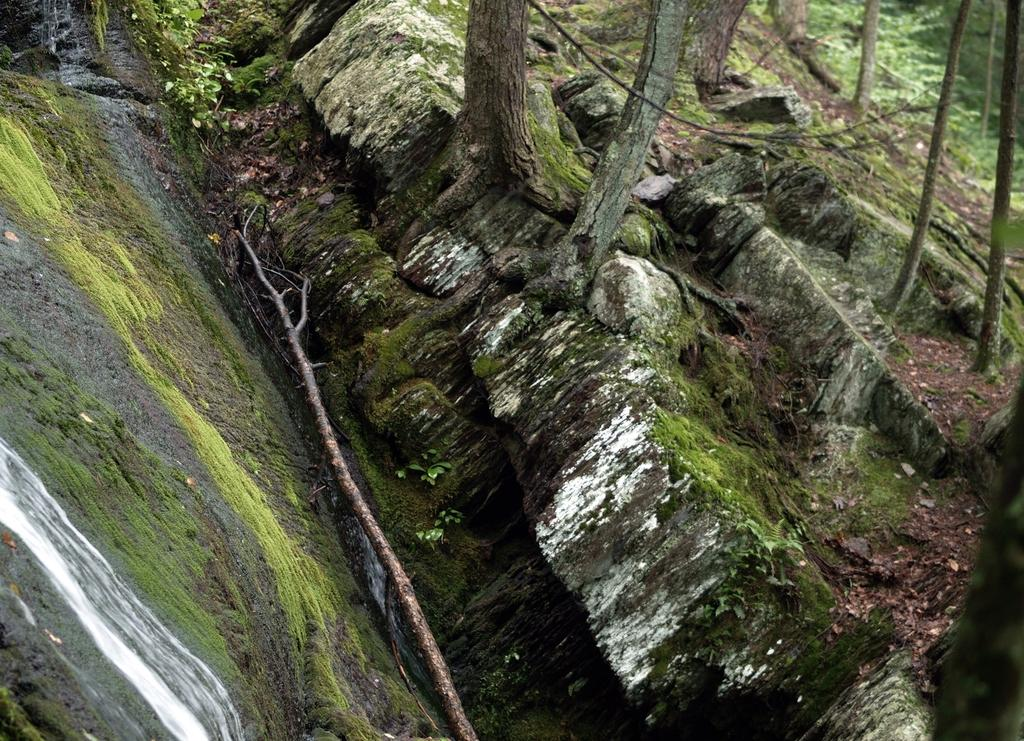What type of natural elements can be seen in the image? There are rocks in the image. What part of the trees can be seen in the image? The trunks of trees are visible at the top of the image. How many women are holding a bomb in the image? There are no women or bombs present in the image. 